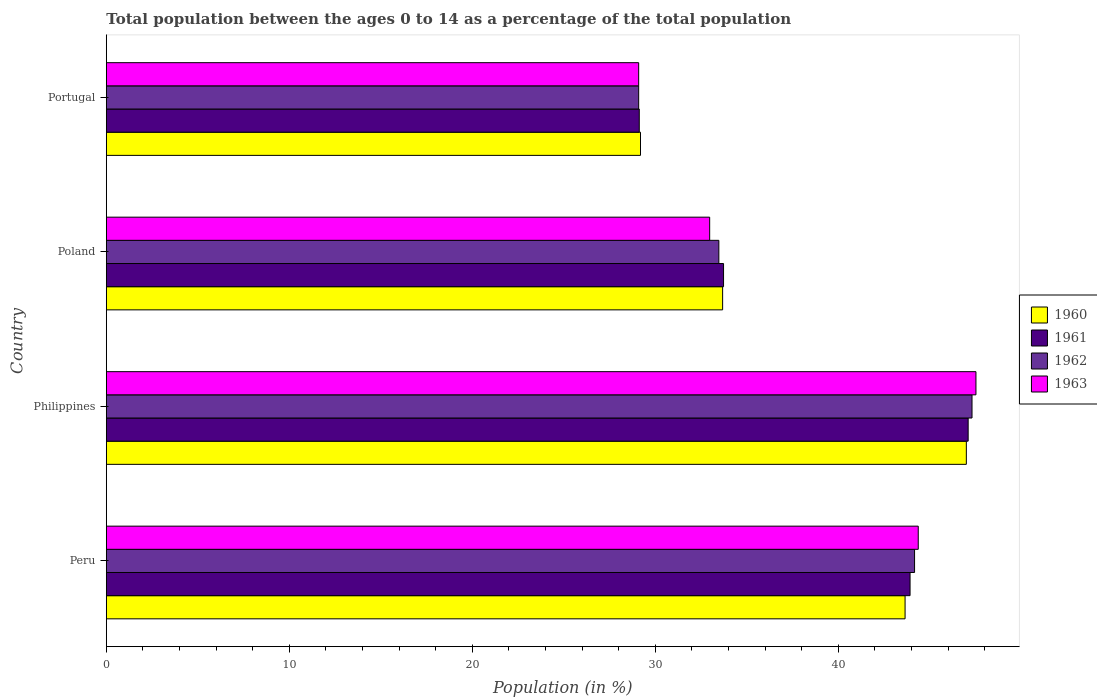How many different coloured bars are there?
Ensure brevity in your answer.  4. How many groups of bars are there?
Provide a succinct answer. 4. Are the number of bars on each tick of the Y-axis equal?
Give a very brief answer. Yes. How many bars are there on the 1st tick from the top?
Your response must be concise. 4. How many bars are there on the 2nd tick from the bottom?
Keep it short and to the point. 4. What is the percentage of the population ages 0 to 14 in 1962 in Portugal?
Provide a short and direct response. 29.09. Across all countries, what is the maximum percentage of the population ages 0 to 14 in 1963?
Your answer should be compact. 47.53. Across all countries, what is the minimum percentage of the population ages 0 to 14 in 1960?
Keep it short and to the point. 29.19. In which country was the percentage of the population ages 0 to 14 in 1960 maximum?
Your answer should be compact. Philippines. In which country was the percentage of the population ages 0 to 14 in 1962 minimum?
Make the answer very short. Portugal. What is the total percentage of the population ages 0 to 14 in 1963 in the graph?
Your response must be concise. 153.97. What is the difference between the percentage of the population ages 0 to 14 in 1961 in Philippines and that in Portugal?
Your response must be concise. 17.97. What is the difference between the percentage of the population ages 0 to 14 in 1960 in Philippines and the percentage of the population ages 0 to 14 in 1963 in Peru?
Give a very brief answer. 2.63. What is the average percentage of the population ages 0 to 14 in 1963 per country?
Make the answer very short. 38.49. What is the difference between the percentage of the population ages 0 to 14 in 1962 and percentage of the population ages 0 to 14 in 1960 in Peru?
Provide a short and direct response. 0.52. What is the ratio of the percentage of the population ages 0 to 14 in 1961 in Peru to that in Portugal?
Keep it short and to the point. 1.51. What is the difference between the highest and the second highest percentage of the population ages 0 to 14 in 1962?
Make the answer very short. 3.14. What is the difference between the highest and the lowest percentage of the population ages 0 to 14 in 1961?
Your answer should be compact. 17.97. In how many countries, is the percentage of the population ages 0 to 14 in 1963 greater than the average percentage of the population ages 0 to 14 in 1963 taken over all countries?
Keep it short and to the point. 2. Is the sum of the percentage of the population ages 0 to 14 in 1962 in Poland and Portugal greater than the maximum percentage of the population ages 0 to 14 in 1963 across all countries?
Your answer should be compact. Yes. What does the 3rd bar from the bottom in Poland represents?
Keep it short and to the point. 1962. Is it the case that in every country, the sum of the percentage of the population ages 0 to 14 in 1962 and percentage of the population ages 0 to 14 in 1963 is greater than the percentage of the population ages 0 to 14 in 1961?
Make the answer very short. Yes. Are all the bars in the graph horizontal?
Give a very brief answer. Yes. Does the graph contain any zero values?
Your answer should be compact. No. Where does the legend appear in the graph?
Your answer should be very brief. Center right. How many legend labels are there?
Your answer should be very brief. 4. What is the title of the graph?
Your answer should be compact. Total population between the ages 0 to 14 as a percentage of the total population. Does "1961" appear as one of the legend labels in the graph?
Give a very brief answer. Yes. What is the label or title of the X-axis?
Your answer should be compact. Population (in %). What is the label or title of the Y-axis?
Your answer should be compact. Country. What is the Population (in %) in 1960 in Peru?
Provide a succinct answer. 43.65. What is the Population (in %) in 1961 in Peru?
Your answer should be very brief. 43.92. What is the Population (in %) in 1962 in Peru?
Your answer should be very brief. 44.17. What is the Population (in %) of 1963 in Peru?
Keep it short and to the point. 44.37. What is the Population (in %) in 1960 in Philippines?
Make the answer very short. 47. What is the Population (in %) of 1961 in Philippines?
Make the answer very short. 47.1. What is the Population (in %) of 1962 in Philippines?
Ensure brevity in your answer.  47.31. What is the Population (in %) of 1963 in Philippines?
Offer a very short reply. 47.53. What is the Population (in %) in 1960 in Poland?
Provide a short and direct response. 33.68. What is the Population (in %) of 1961 in Poland?
Make the answer very short. 33.73. What is the Population (in %) in 1962 in Poland?
Your answer should be very brief. 33.47. What is the Population (in %) of 1963 in Poland?
Provide a short and direct response. 32.97. What is the Population (in %) in 1960 in Portugal?
Make the answer very short. 29.19. What is the Population (in %) in 1961 in Portugal?
Keep it short and to the point. 29.13. What is the Population (in %) of 1962 in Portugal?
Your answer should be very brief. 29.09. What is the Population (in %) of 1963 in Portugal?
Ensure brevity in your answer.  29.09. Across all countries, what is the maximum Population (in %) in 1960?
Provide a short and direct response. 47. Across all countries, what is the maximum Population (in %) in 1961?
Give a very brief answer. 47.1. Across all countries, what is the maximum Population (in %) of 1962?
Your response must be concise. 47.31. Across all countries, what is the maximum Population (in %) in 1963?
Your answer should be compact. 47.53. Across all countries, what is the minimum Population (in %) of 1960?
Offer a terse response. 29.19. Across all countries, what is the minimum Population (in %) in 1961?
Provide a succinct answer. 29.13. Across all countries, what is the minimum Population (in %) in 1962?
Offer a very short reply. 29.09. Across all countries, what is the minimum Population (in %) of 1963?
Give a very brief answer. 29.09. What is the total Population (in %) in 1960 in the graph?
Your answer should be compact. 153.53. What is the total Population (in %) in 1961 in the graph?
Give a very brief answer. 153.88. What is the total Population (in %) of 1962 in the graph?
Keep it short and to the point. 154.05. What is the total Population (in %) of 1963 in the graph?
Offer a very short reply. 153.97. What is the difference between the Population (in %) in 1960 in Peru and that in Philippines?
Your answer should be very brief. -3.35. What is the difference between the Population (in %) in 1961 in Peru and that in Philippines?
Offer a very short reply. -3.18. What is the difference between the Population (in %) in 1962 in Peru and that in Philippines?
Your answer should be very brief. -3.14. What is the difference between the Population (in %) in 1963 in Peru and that in Philippines?
Offer a very short reply. -3.15. What is the difference between the Population (in %) of 1960 in Peru and that in Poland?
Provide a succinct answer. 9.97. What is the difference between the Population (in %) in 1961 in Peru and that in Poland?
Your response must be concise. 10.19. What is the difference between the Population (in %) in 1962 in Peru and that in Poland?
Your response must be concise. 10.7. What is the difference between the Population (in %) in 1963 in Peru and that in Poland?
Ensure brevity in your answer.  11.4. What is the difference between the Population (in %) of 1960 in Peru and that in Portugal?
Ensure brevity in your answer.  14.46. What is the difference between the Population (in %) of 1961 in Peru and that in Portugal?
Provide a succinct answer. 14.8. What is the difference between the Population (in %) in 1962 in Peru and that in Portugal?
Give a very brief answer. 15.08. What is the difference between the Population (in %) in 1963 in Peru and that in Portugal?
Provide a short and direct response. 15.28. What is the difference between the Population (in %) in 1960 in Philippines and that in Poland?
Offer a terse response. 13.32. What is the difference between the Population (in %) of 1961 in Philippines and that in Poland?
Ensure brevity in your answer.  13.37. What is the difference between the Population (in %) of 1962 in Philippines and that in Poland?
Offer a very short reply. 13.84. What is the difference between the Population (in %) of 1963 in Philippines and that in Poland?
Offer a terse response. 14.55. What is the difference between the Population (in %) in 1960 in Philippines and that in Portugal?
Offer a very short reply. 17.81. What is the difference between the Population (in %) of 1961 in Philippines and that in Portugal?
Provide a short and direct response. 17.97. What is the difference between the Population (in %) in 1962 in Philippines and that in Portugal?
Keep it short and to the point. 18.22. What is the difference between the Population (in %) in 1963 in Philippines and that in Portugal?
Provide a short and direct response. 18.43. What is the difference between the Population (in %) in 1960 in Poland and that in Portugal?
Keep it short and to the point. 4.49. What is the difference between the Population (in %) of 1961 in Poland and that in Portugal?
Give a very brief answer. 4.61. What is the difference between the Population (in %) in 1962 in Poland and that in Portugal?
Your answer should be very brief. 4.38. What is the difference between the Population (in %) of 1963 in Poland and that in Portugal?
Your response must be concise. 3.88. What is the difference between the Population (in %) in 1960 in Peru and the Population (in %) in 1961 in Philippines?
Ensure brevity in your answer.  -3.45. What is the difference between the Population (in %) of 1960 in Peru and the Population (in %) of 1962 in Philippines?
Give a very brief answer. -3.66. What is the difference between the Population (in %) in 1960 in Peru and the Population (in %) in 1963 in Philippines?
Your answer should be compact. -3.87. What is the difference between the Population (in %) of 1961 in Peru and the Population (in %) of 1962 in Philippines?
Offer a terse response. -3.39. What is the difference between the Population (in %) in 1961 in Peru and the Population (in %) in 1963 in Philippines?
Keep it short and to the point. -3.6. What is the difference between the Population (in %) of 1962 in Peru and the Population (in %) of 1963 in Philippines?
Your answer should be very brief. -3.36. What is the difference between the Population (in %) in 1960 in Peru and the Population (in %) in 1961 in Poland?
Ensure brevity in your answer.  9.92. What is the difference between the Population (in %) in 1960 in Peru and the Population (in %) in 1962 in Poland?
Offer a very short reply. 10.18. What is the difference between the Population (in %) of 1960 in Peru and the Population (in %) of 1963 in Poland?
Your response must be concise. 10.68. What is the difference between the Population (in %) of 1961 in Peru and the Population (in %) of 1962 in Poland?
Your answer should be compact. 10.45. What is the difference between the Population (in %) of 1961 in Peru and the Population (in %) of 1963 in Poland?
Offer a very short reply. 10.95. What is the difference between the Population (in %) in 1962 in Peru and the Population (in %) in 1963 in Poland?
Provide a short and direct response. 11.2. What is the difference between the Population (in %) of 1960 in Peru and the Population (in %) of 1961 in Portugal?
Your answer should be compact. 14.53. What is the difference between the Population (in %) of 1960 in Peru and the Population (in %) of 1962 in Portugal?
Give a very brief answer. 14.56. What is the difference between the Population (in %) of 1960 in Peru and the Population (in %) of 1963 in Portugal?
Ensure brevity in your answer.  14.56. What is the difference between the Population (in %) in 1961 in Peru and the Population (in %) in 1962 in Portugal?
Ensure brevity in your answer.  14.83. What is the difference between the Population (in %) of 1961 in Peru and the Population (in %) of 1963 in Portugal?
Your answer should be very brief. 14.83. What is the difference between the Population (in %) in 1962 in Peru and the Population (in %) in 1963 in Portugal?
Your response must be concise. 15.08. What is the difference between the Population (in %) in 1960 in Philippines and the Population (in %) in 1961 in Poland?
Make the answer very short. 13.27. What is the difference between the Population (in %) of 1960 in Philippines and the Population (in %) of 1962 in Poland?
Ensure brevity in your answer.  13.53. What is the difference between the Population (in %) in 1960 in Philippines and the Population (in %) in 1963 in Poland?
Offer a terse response. 14.03. What is the difference between the Population (in %) of 1961 in Philippines and the Population (in %) of 1962 in Poland?
Make the answer very short. 13.63. What is the difference between the Population (in %) in 1961 in Philippines and the Population (in %) in 1963 in Poland?
Give a very brief answer. 14.13. What is the difference between the Population (in %) in 1962 in Philippines and the Population (in %) in 1963 in Poland?
Provide a short and direct response. 14.34. What is the difference between the Population (in %) in 1960 in Philippines and the Population (in %) in 1961 in Portugal?
Ensure brevity in your answer.  17.88. What is the difference between the Population (in %) of 1960 in Philippines and the Population (in %) of 1962 in Portugal?
Offer a very short reply. 17.91. What is the difference between the Population (in %) of 1960 in Philippines and the Population (in %) of 1963 in Portugal?
Offer a very short reply. 17.91. What is the difference between the Population (in %) of 1961 in Philippines and the Population (in %) of 1962 in Portugal?
Provide a succinct answer. 18.01. What is the difference between the Population (in %) in 1961 in Philippines and the Population (in %) in 1963 in Portugal?
Offer a very short reply. 18.01. What is the difference between the Population (in %) of 1962 in Philippines and the Population (in %) of 1963 in Portugal?
Offer a terse response. 18.22. What is the difference between the Population (in %) in 1960 in Poland and the Population (in %) in 1961 in Portugal?
Your answer should be compact. 4.56. What is the difference between the Population (in %) in 1960 in Poland and the Population (in %) in 1962 in Portugal?
Provide a succinct answer. 4.59. What is the difference between the Population (in %) in 1960 in Poland and the Population (in %) in 1963 in Portugal?
Offer a very short reply. 4.59. What is the difference between the Population (in %) of 1961 in Poland and the Population (in %) of 1962 in Portugal?
Your answer should be compact. 4.64. What is the difference between the Population (in %) in 1961 in Poland and the Population (in %) in 1963 in Portugal?
Ensure brevity in your answer.  4.64. What is the difference between the Population (in %) in 1962 in Poland and the Population (in %) in 1963 in Portugal?
Keep it short and to the point. 4.38. What is the average Population (in %) of 1960 per country?
Your answer should be compact. 38.38. What is the average Population (in %) in 1961 per country?
Your response must be concise. 38.47. What is the average Population (in %) of 1962 per country?
Ensure brevity in your answer.  38.51. What is the average Population (in %) of 1963 per country?
Keep it short and to the point. 38.49. What is the difference between the Population (in %) in 1960 and Population (in %) in 1961 in Peru?
Provide a short and direct response. -0.27. What is the difference between the Population (in %) in 1960 and Population (in %) in 1962 in Peru?
Provide a succinct answer. -0.52. What is the difference between the Population (in %) in 1960 and Population (in %) in 1963 in Peru?
Ensure brevity in your answer.  -0.72. What is the difference between the Population (in %) of 1961 and Population (in %) of 1962 in Peru?
Offer a very short reply. -0.25. What is the difference between the Population (in %) in 1961 and Population (in %) in 1963 in Peru?
Provide a short and direct response. -0.45. What is the difference between the Population (in %) of 1962 and Population (in %) of 1963 in Peru?
Give a very brief answer. -0.2. What is the difference between the Population (in %) in 1960 and Population (in %) in 1961 in Philippines?
Offer a terse response. -0.1. What is the difference between the Population (in %) of 1960 and Population (in %) of 1962 in Philippines?
Your answer should be very brief. -0.31. What is the difference between the Population (in %) in 1960 and Population (in %) in 1963 in Philippines?
Give a very brief answer. -0.53. What is the difference between the Population (in %) in 1961 and Population (in %) in 1962 in Philippines?
Offer a terse response. -0.21. What is the difference between the Population (in %) in 1961 and Population (in %) in 1963 in Philippines?
Provide a short and direct response. -0.43. What is the difference between the Population (in %) in 1962 and Population (in %) in 1963 in Philippines?
Your response must be concise. -0.21. What is the difference between the Population (in %) of 1960 and Population (in %) of 1961 in Poland?
Offer a terse response. -0.05. What is the difference between the Population (in %) in 1960 and Population (in %) in 1962 in Poland?
Keep it short and to the point. 0.21. What is the difference between the Population (in %) in 1960 and Population (in %) in 1963 in Poland?
Keep it short and to the point. 0.71. What is the difference between the Population (in %) of 1961 and Population (in %) of 1962 in Poland?
Provide a short and direct response. 0.26. What is the difference between the Population (in %) in 1961 and Population (in %) in 1963 in Poland?
Ensure brevity in your answer.  0.76. What is the difference between the Population (in %) of 1962 and Population (in %) of 1963 in Poland?
Provide a short and direct response. 0.5. What is the difference between the Population (in %) in 1960 and Population (in %) in 1961 in Portugal?
Offer a terse response. 0.07. What is the difference between the Population (in %) in 1960 and Population (in %) in 1962 in Portugal?
Give a very brief answer. 0.1. What is the difference between the Population (in %) in 1960 and Population (in %) in 1963 in Portugal?
Make the answer very short. 0.1. What is the difference between the Population (in %) in 1961 and Population (in %) in 1962 in Portugal?
Make the answer very short. 0.03. What is the difference between the Population (in %) in 1961 and Population (in %) in 1963 in Portugal?
Your response must be concise. 0.03. What is the difference between the Population (in %) of 1962 and Population (in %) of 1963 in Portugal?
Offer a very short reply. 0. What is the ratio of the Population (in %) in 1960 in Peru to that in Philippines?
Your response must be concise. 0.93. What is the ratio of the Population (in %) in 1961 in Peru to that in Philippines?
Provide a succinct answer. 0.93. What is the ratio of the Population (in %) of 1962 in Peru to that in Philippines?
Give a very brief answer. 0.93. What is the ratio of the Population (in %) in 1963 in Peru to that in Philippines?
Your answer should be very brief. 0.93. What is the ratio of the Population (in %) of 1960 in Peru to that in Poland?
Provide a succinct answer. 1.3. What is the ratio of the Population (in %) in 1961 in Peru to that in Poland?
Offer a terse response. 1.3. What is the ratio of the Population (in %) of 1962 in Peru to that in Poland?
Offer a very short reply. 1.32. What is the ratio of the Population (in %) of 1963 in Peru to that in Poland?
Offer a very short reply. 1.35. What is the ratio of the Population (in %) of 1960 in Peru to that in Portugal?
Your response must be concise. 1.5. What is the ratio of the Population (in %) in 1961 in Peru to that in Portugal?
Give a very brief answer. 1.51. What is the ratio of the Population (in %) in 1962 in Peru to that in Portugal?
Offer a terse response. 1.52. What is the ratio of the Population (in %) of 1963 in Peru to that in Portugal?
Ensure brevity in your answer.  1.53. What is the ratio of the Population (in %) of 1960 in Philippines to that in Poland?
Give a very brief answer. 1.4. What is the ratio of the Population (in %) in 1961 in Philippines to that in Poland?
Provide a succinct answer. 1.4. What is the ratio of the Population (in %) of 1962 in Philippines to that in Poland?
Ensure brevity in your answer.  1.41. What is the ratio of the Population (in %) of 1963 in Philippines to that in Poland?
Provide a short and direct response. 1.44. What is the ratio of the Population (in %) of 1960 in Philippines to that in Portugal?
Keep it short and to the point. 1.61. What is the ratio of the Population (in %) in 1961 in Philippines to that in Portugal?
Offer a terse response. 1.62. What is the ratio of the Population (in %) in 1962 in Philippines to that in Portugal?
Your answer should be compact. 1.63. What is the ratio of the Population (in %) in 1963 in Philippines to that in Portugal?
Your answer should be compact. 1.63. What is the ratio of the Population (in %) of 1960 in Poland to that in Portugal?
Give a very brief answer. 1.15. What is the ratio of the Population (in %) of 1961 in Poland to that in Portugal?
Your answer should be very brief. 1.16. What is the ratio of the Population (in %) in 1962 in Poland to that in Portugal?
Ensure brevity in your answer.  1.15. What is the ratio of the Population (in %) of 1963 in Poland to that in Portugal?
Provide a short and direct response. 1.13. What is the difference between the highest and the second highest Population (in %) of 1960?
Provide a short and direct response. 3.35. What is the difference between the highest and the second highest Population (in %) of 1961?
Offer a terse response. 3.18. What is the difference between the highest and the second highest Population (in %) in 1962?
Your response must be concise. 3.14. What is the difference between the highest and the second highest Population (in %) in 1963?
Keep it short and to the point. 3.15. What is the difference between the highest and the lowest Population (in %) in 1960?
Your response must be concise. 17.81. What is the difference between the highest and the lowest Population (in %) in 1961?
Make the answer very short. 17.97. What is the difference between the highest and the lowest Population (in %) in 1962?
Provide a succinct answer. 18.22. What is the difference between the highest and the lowest Population (in %) of 1963?
Your answer should be compact. 18.43. 